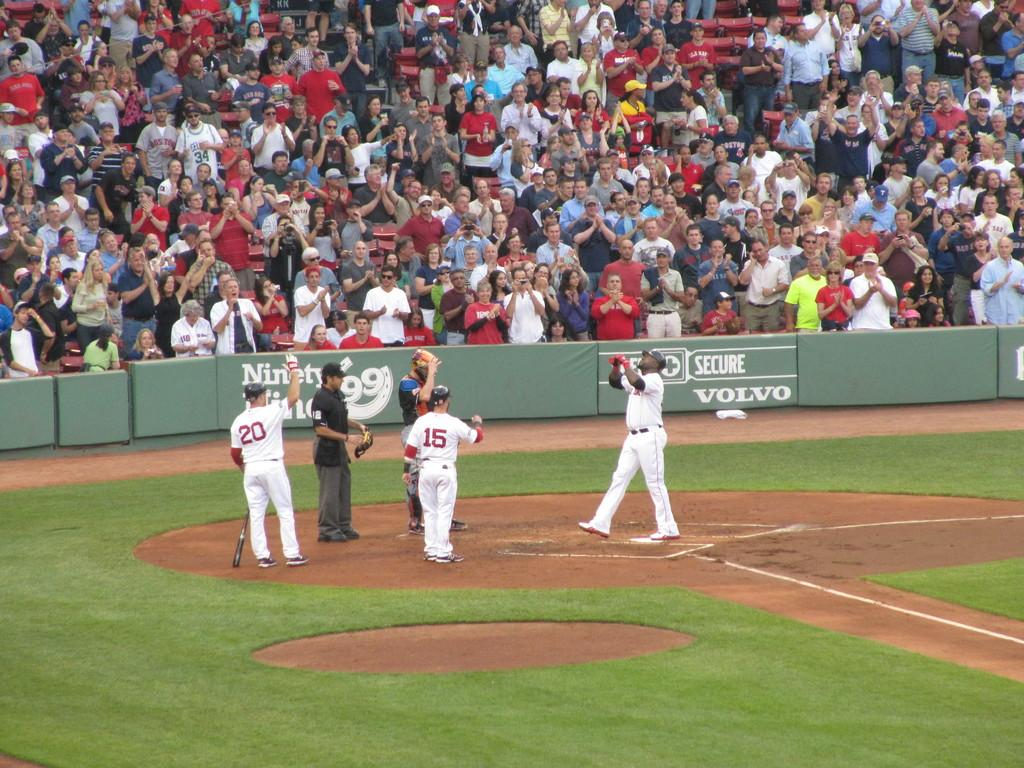<image>
Relay a brief, clear account of the picture shown. a group of players with one wearing 15 